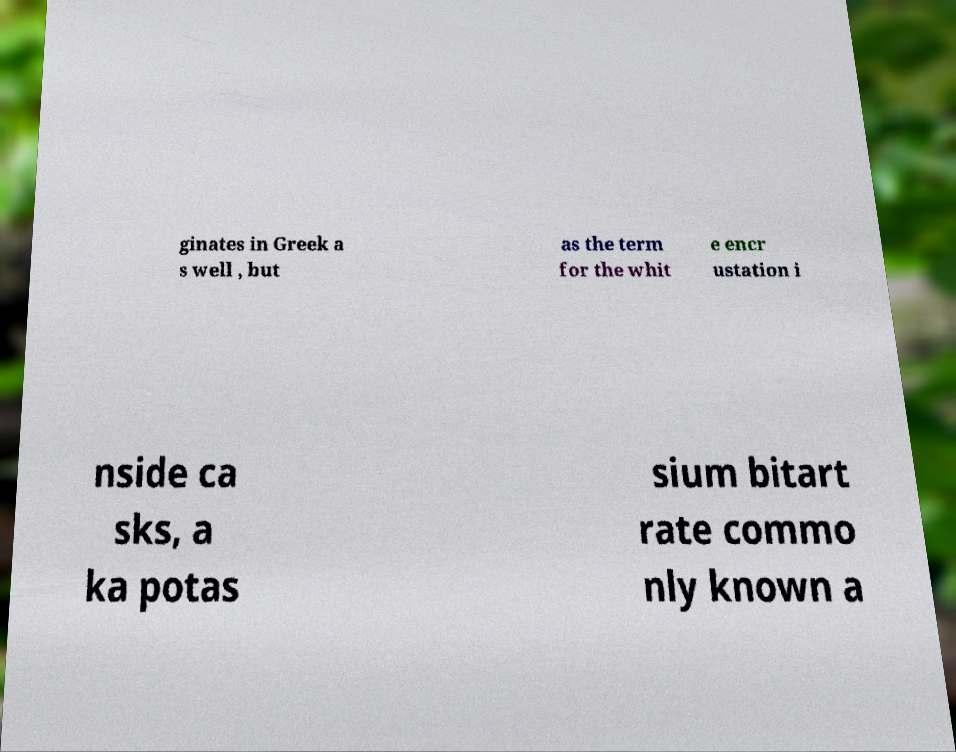Please read and relay the text visible in this image. What does it say? ginates in Greek a s well , but as the term for the whit e encr ustation i nside ca sks, a ka potas sium bitart rate commo nly known a 